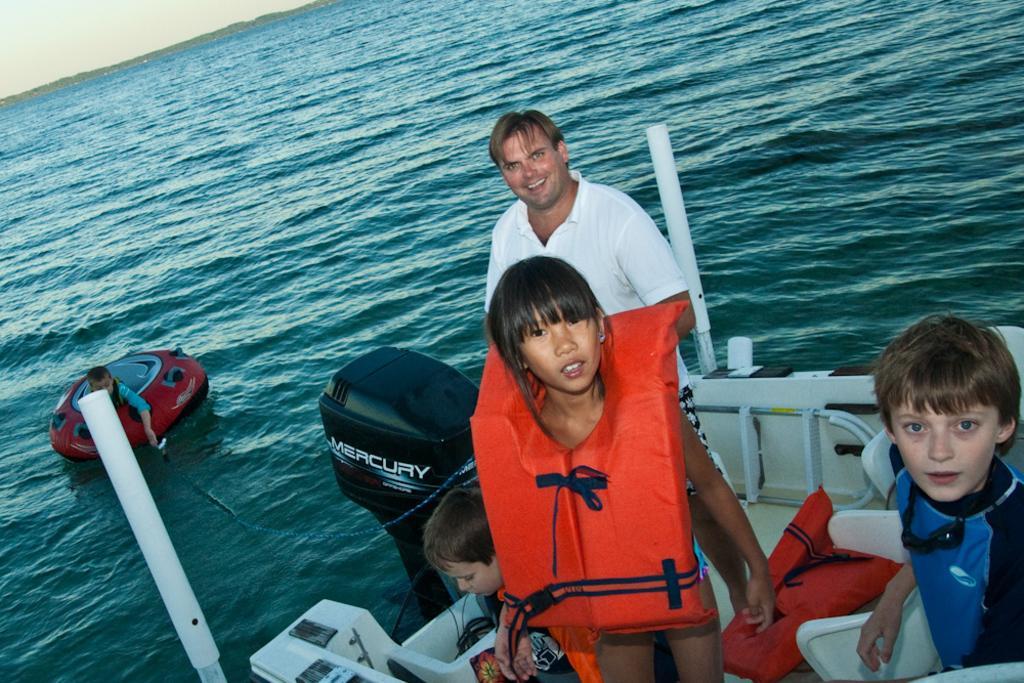Could you give a brief overview of what you see in this image? In this picture there are two persons standing and smiling and there are two persons sitting on the boat. At back there is a person sitting on the tube. At the bottom there is water. At the back there are trees. At the top there is sky. 